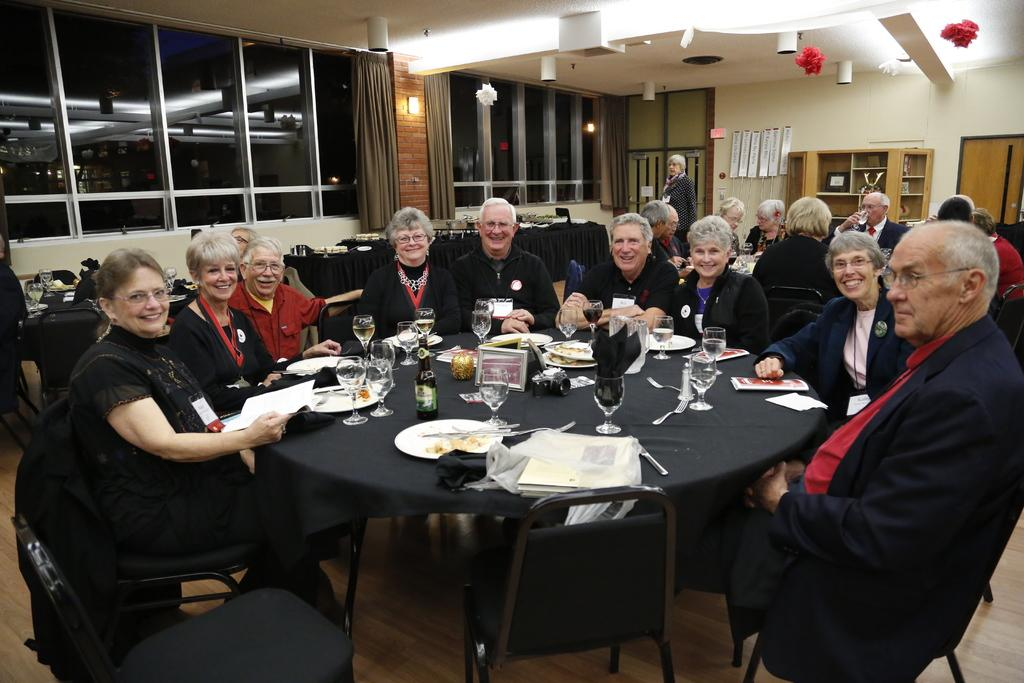What are the people in the image doing? There is a group of people sitting around a table. What is on the table with the people? There are eatables and drinks on the table. Can you describe the setting of the image? There are people in the background of the image. How many bananas are being held by the people in the image? There is no mention of bananas in the image, so it cannot be determined how many are being held. 